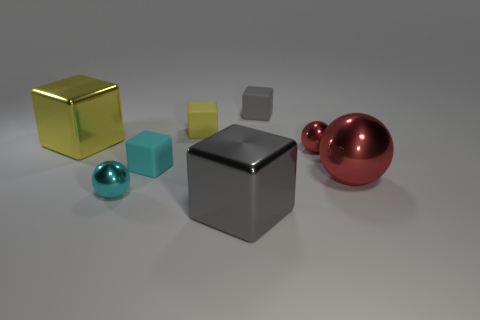Subtract 1 blocks. How many blocks are left? 4 Subtract all cyan blocks. How many blocks are left? 4 Subtract all small cyan blocks. How many blocks are left? 4 Subtract all blue blocks. Subtract all gray spheres. How many blocks are left? 5 Add 1 yellow metallic cubes. How many objects exist? 9 Subtract all cubes. How many objects are left? 3 Subtract all big brown matte blocks. Subtract all large metal balls. How many objects are left? 7 Add 2 big red shiny spheres. How many big red shiny spheres are left? 3 Add 5 metallic objects. How many metallic objects exist? 10 Subtract 0 green balls. How many objects are left? 8 